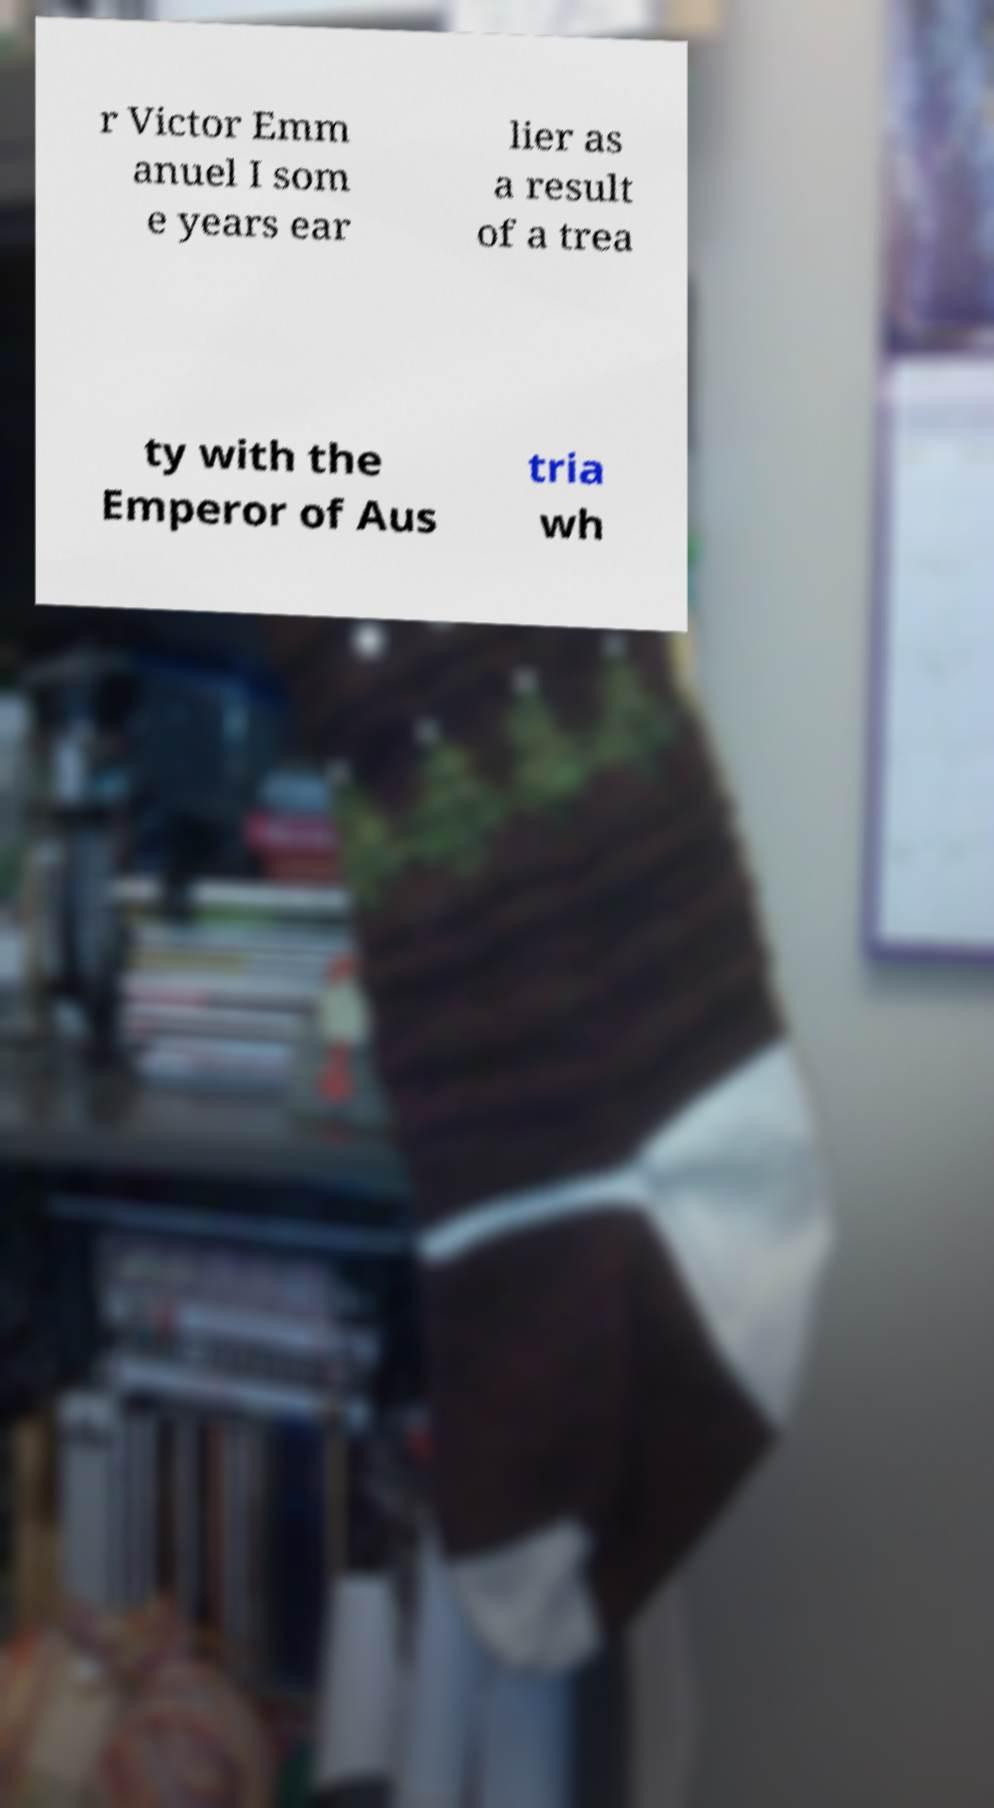For documentation purposes, I need the text within this image transcribed. Could you provide that? r Victor Emm anuel I som e years ear lier as a result of a trea ty with the Emperor of Aus tria wh 